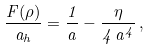Convert formula to latex. <formula><loc_0><loc_0><loc_500><loc_500>\frac { F ( \rho ) } { a _ { h } } = \frac { 1 } { a } - \frac { \eta } { 4 \, a ^ { 4 } } \, ,</formula> 